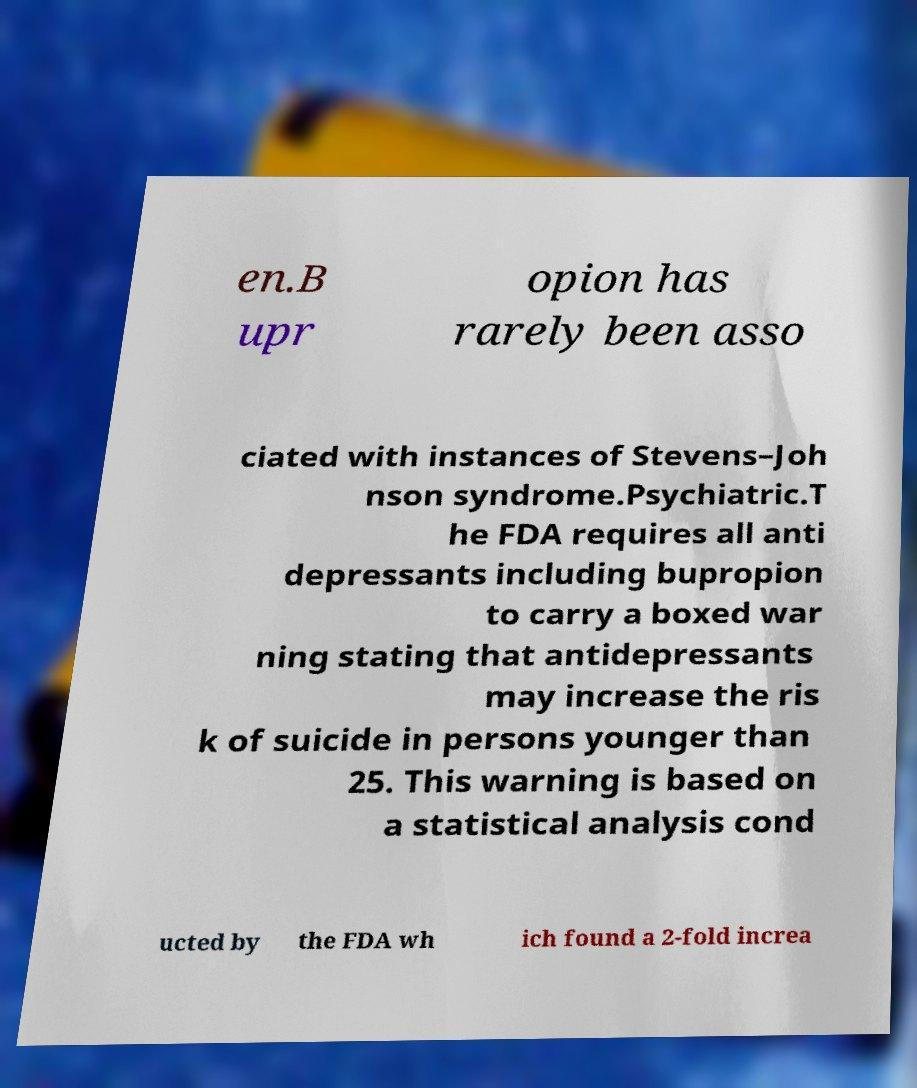Can you read and provide the text displayed in the image?This photo seems to have some interesting text. Can you extract and type it out for me? en.B upr opion has rarely been asso ciated with instances of Stevens–Joh nson syndrome.Psychiatric.T he FDA requires all anti depressants including bupropion to carry a boxed war ning stating that antidepressants may increase the ris k of suicide in persons younger than 25. This warning is based on a statistical analysis cond ucted by the FDA wh ich found a 2-fold increa 